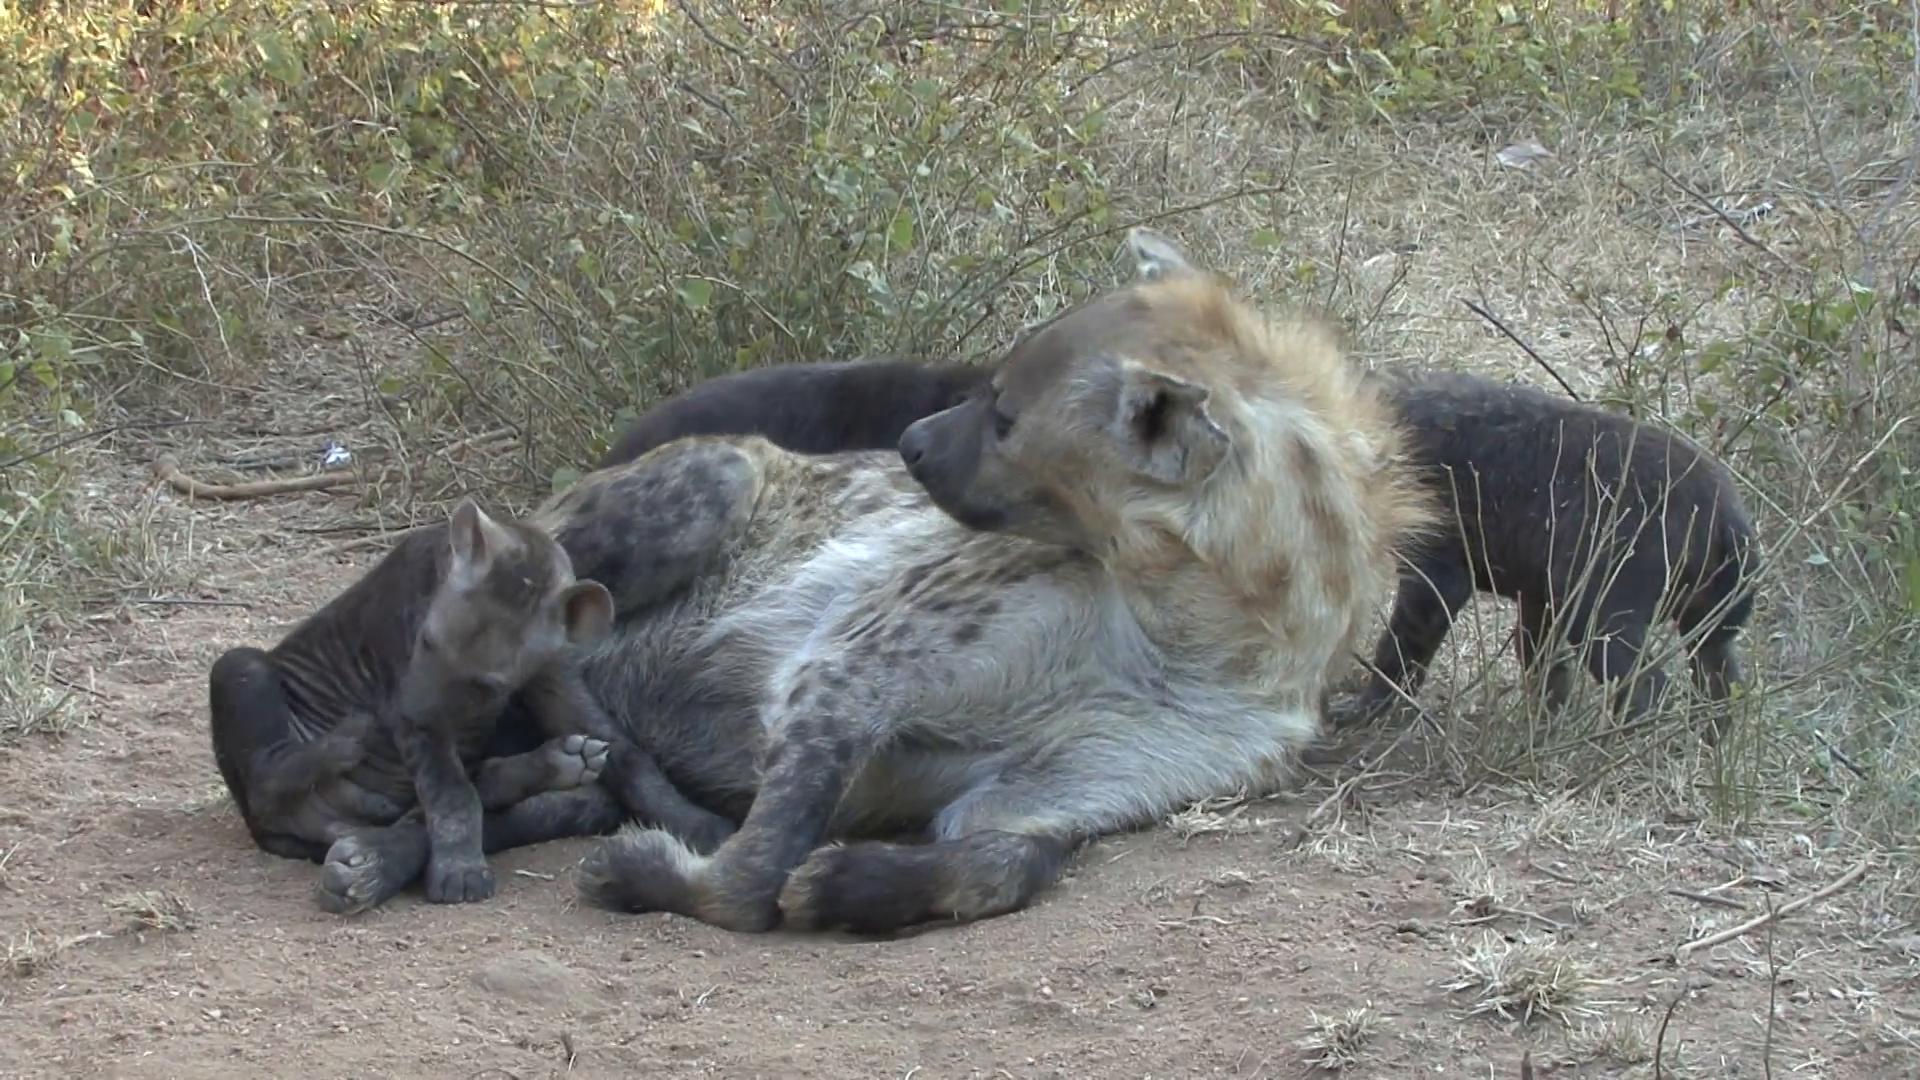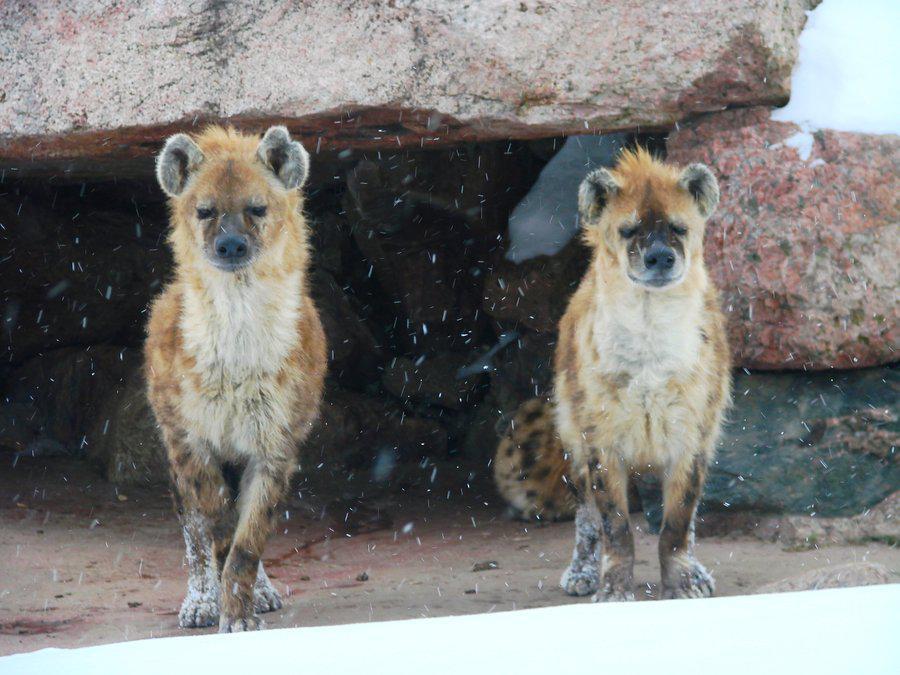The first image is the image on the left, the second image is the image on the right. Given the left and right images, does the statement "The hyena in the foreground of the left image is walking forward at a rightward angle with its head lowered and one front paw off the ground and bent inward." hold true? Answer yes or no. No. The first image is the image on the left, the second image is the image on the right. Considering the images on both sides, is "There are two hyenas in the right image." valid? Answer yes or no. Yes. 